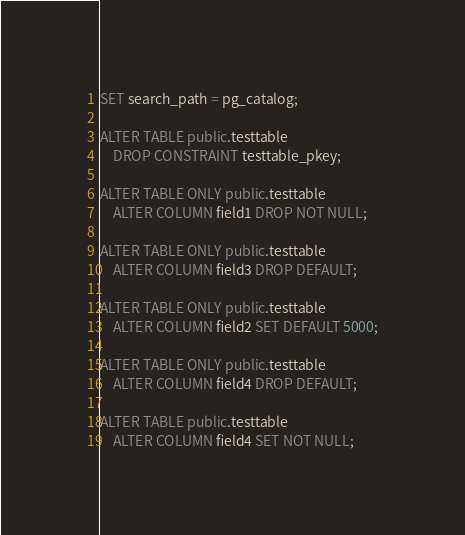Convert code to text. <code><loc_0><loc_0><loc_500><loc_500><_SQL_>SET search_path = pg_catalog;

ALTER TABLE public.testtable
	DROP CONSTRAINT testtable_pkey;

ALTER TABLE ONLY public.testtable
	ALTER COLUMN field1 DROP NOT NULL;

ALTER TABLE ONLY public.testtable
	ALTER COLUMN field3 DROP DEFAULT;

ALTER TABLE ONLY public.testtable
	ALTER COLUMN field2 SET DEFAULT 5000;

ALTER TABLE ONLY public.testtable
	ALTER COLUMN field4 DROP DEFAULT;

ALTER TABLE public.testtable
	ALTER COLUMN field4 SET NOT NULL;
</code> 